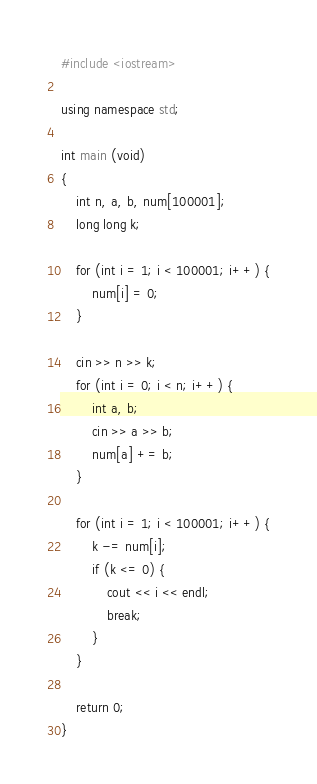Convert code to text. <code><loc_0><loc_0><loc_500><loc_500><_C++_>#include <iostream>

using namespace std;

int main (void)
{
    int n, a, b, num[100001];
    long long k;

    for (int i = 1; i < 100001; i++) {
        num[i] = 0;
    }

    cin >> n >> k;
    for (int i = 0; i < n; i++) {
        int a, b;
        cin >> a >> b;
        num[a] += b;
    }

    for (int i = 1; i < 100001; i++) {
        k -= num[i];
        if (k <= 0) {
            cout << i << endl;
            break;
        }
    }

    return 0;
}</code> 